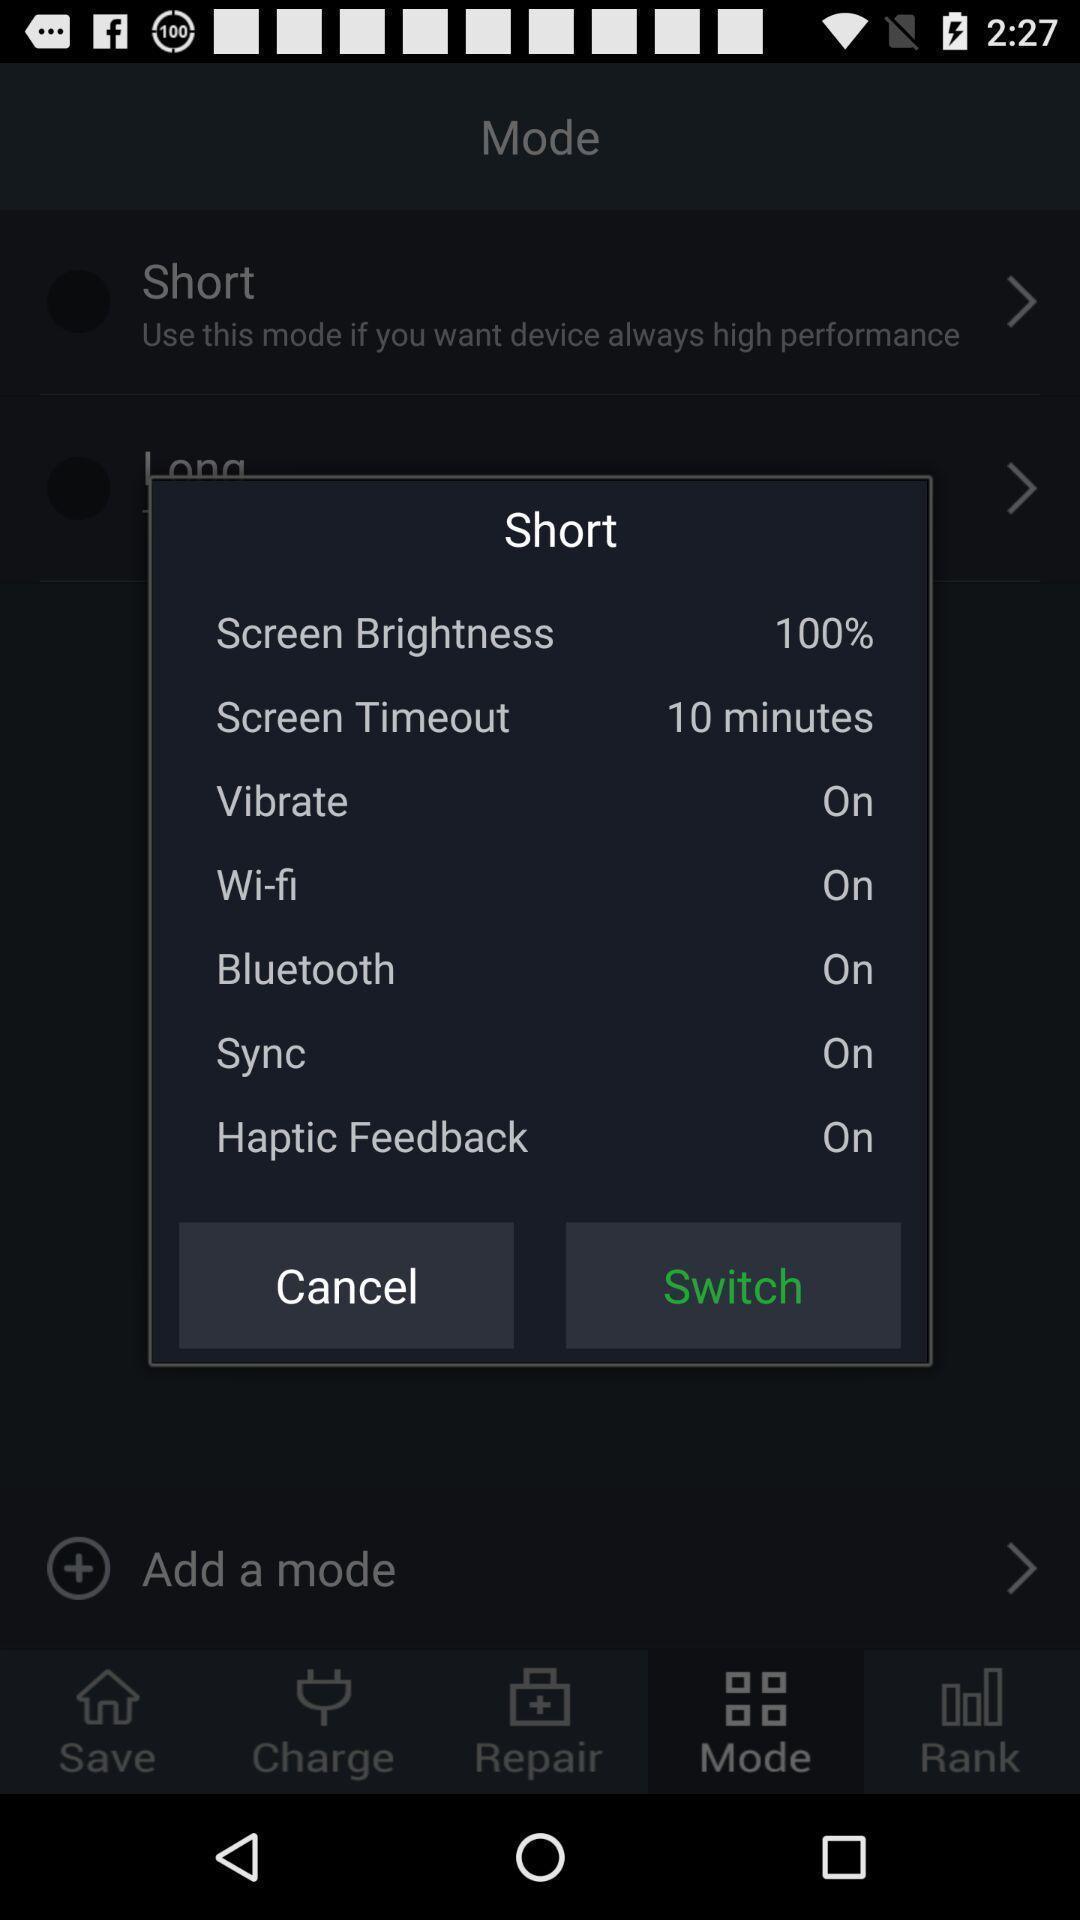Provide a detailed account of this screenshot. Pop-up with a setting information. 